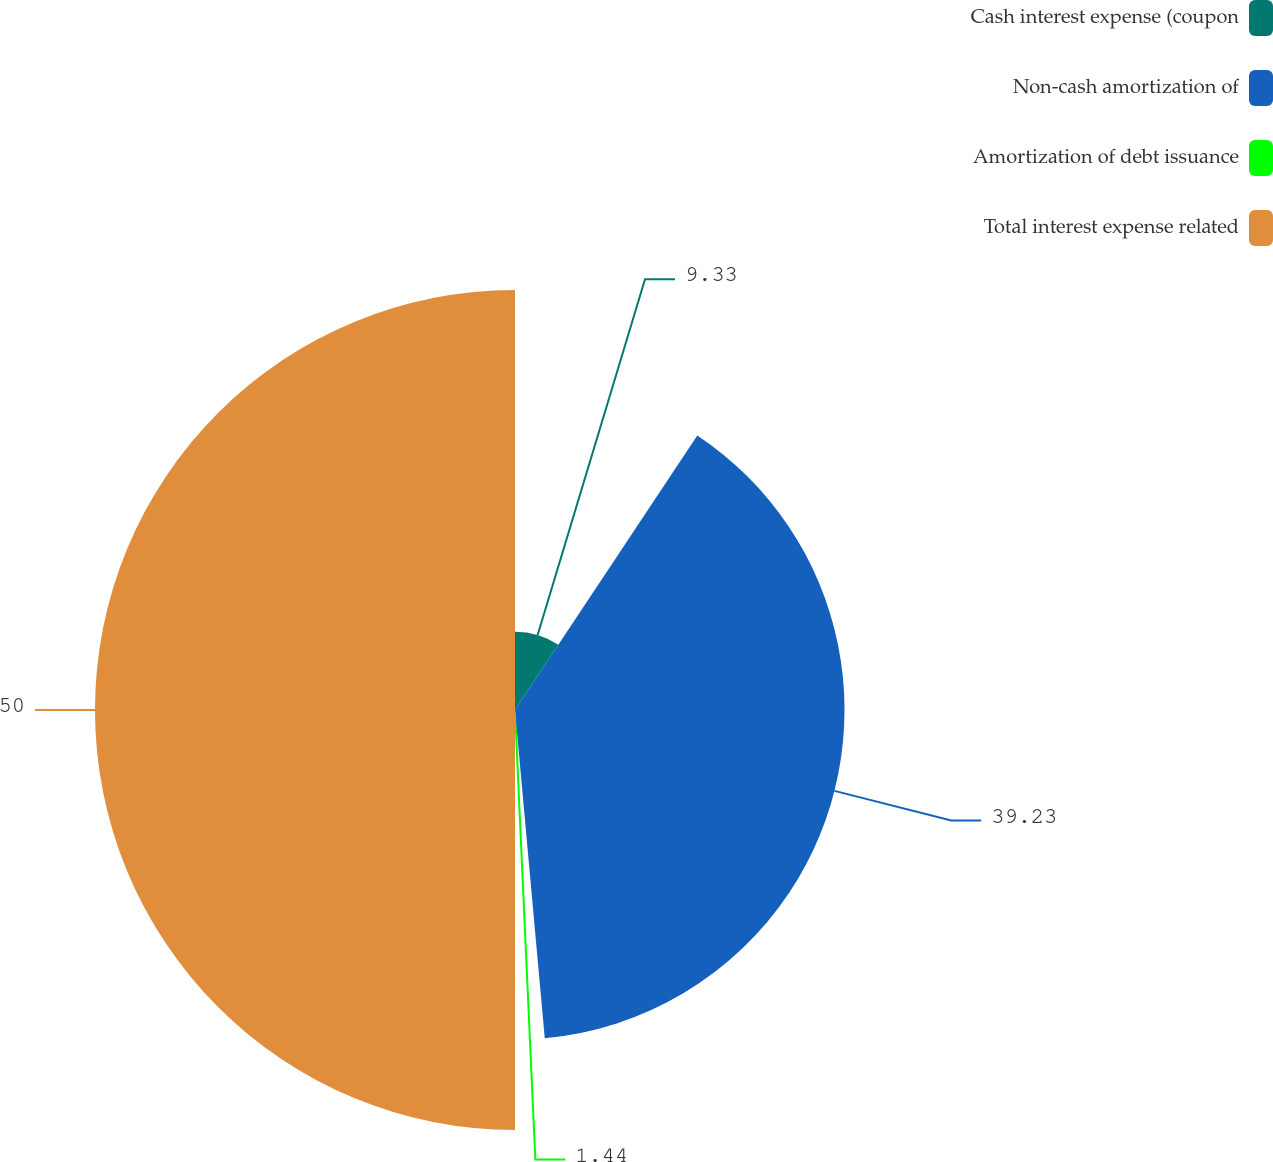Convert chart to OTSL. <chart><loc_0><loc_0><loc_500><loc_500><pie_chart><fcel>Cash interest expense (coupon<fcel>Non-cash amortization of<fcel>Amortization of debt issuance<fcel>Total interest expense related<nl><fcel>9.33%<fcel>39.23%<fcel>1.44%<fcel>50.0%<nl></chart> 